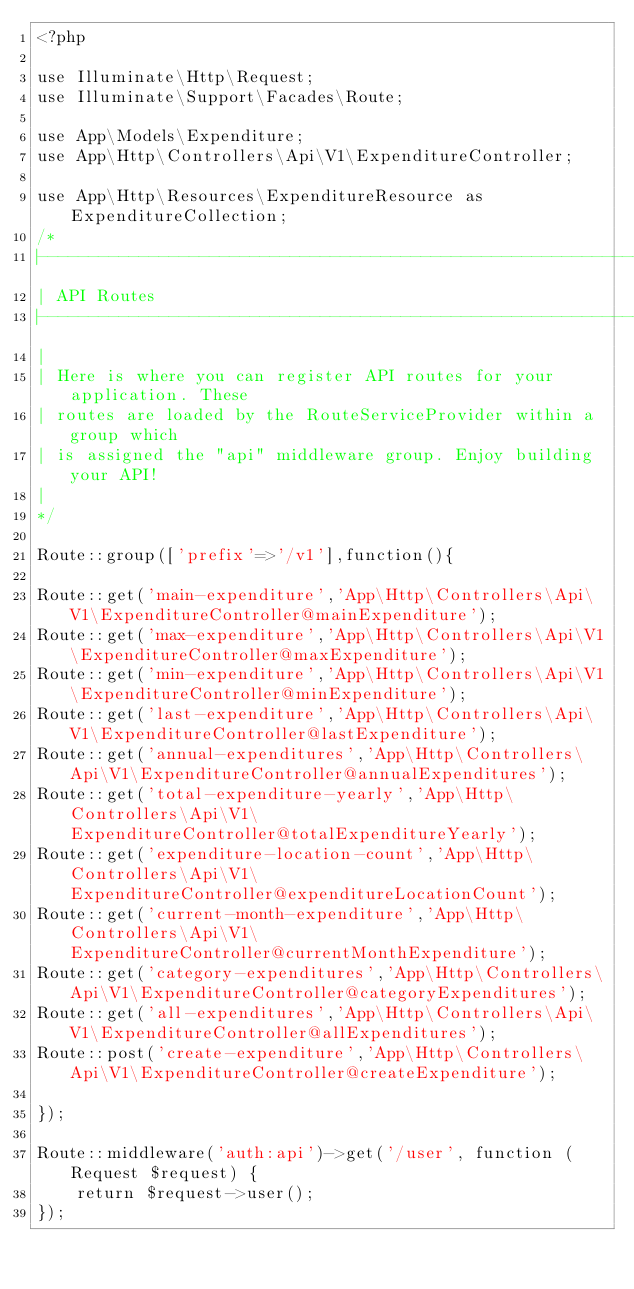Convert code to text. <code><loc_0><loc_0><loc_500><loc_500><_PHP_><?php

use Illuminate\Http\Request;
use Illuminate\Support\Facades\Route;

use App\Models\Expenditure;
use App\Http\Controllers\Api\V1\ExpenditureController;

use App\Http\Resources\ExpenditureResource as ExpenditureCollection;
/*
|--------------------------------------------------------------------------
| API Routes
|--------------------------------------------------------------------------
|
| Here is where you can register API routes for your application. These
| routes are loaded by the RouteServiceProvider within a group which
| is assigned the "api" middleware group. Enjoy building your API!
|
*/

Route::group(['prefix'=>'/v1'],function(){

Route::get('main-expenditure','App\Http\Controllers\Api\V1\ExpenditureController@mainExpenditure');
Route::get('max-expenditure','App\Http\Controllers\Api\V1\ExpenditureController@maxExpenditure');
Route::get('min-expenditure','App\Http\Controllers\Api\V1\ExpenditureController@minExpenditure');
Route::get('last-expenditure','App\Http\Controllers\Api\V1\ExpenditureController@lastExpenditure');
Route::get('annual-expenditures','App\Http\Controllers\Api\V1\ExpenditureController@annualExpenditures');
Route::get('total-expenditure-yearly','App\Http\Controllers\Api\V1\ExpenditureController@totalExpenditureYearly');
Route::get('expenditure-location-count','App\Http\Controllers\Api\V1\ExpenditureController@expenditureLocationCount');
Route::get('current-month-expenditure','App\Http\Controllers\Api\V1\ExpenditureController@currentMonthExpenditure');
Route::get('category-expenditures','App\Http\Controllers\Api\V1\ExpenditureController@categoryExpenditures');
Route::get('all-expenditures','App\Http\Controllers\Api\V1\ExpenditureController@allExpenditures');
Route::post('create-expenditure','App\Http\Controllers\Api\V1\ExpenditureController@createExpenditure');

});

Route::middleware('auth:api')->get('/user', function (Request $request) {
    return $request->user();
});
</code> 